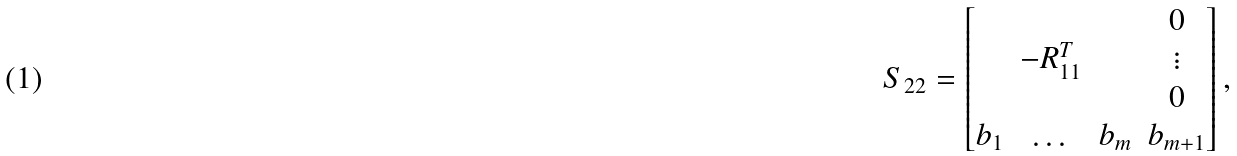<formula> <loc_0><loc_0><loc_500><loc_500>S _ { 2 2 } = \begin{bmatrix} & & & 0 \\ & - R _ { 1 1 } ^ { T } & & \vdots \\ & & & 0 \\ b _ { 1 } & \dots & b _ { m } & b _ { m + 1 } \\ \end{bmatrix} ,</formula> 